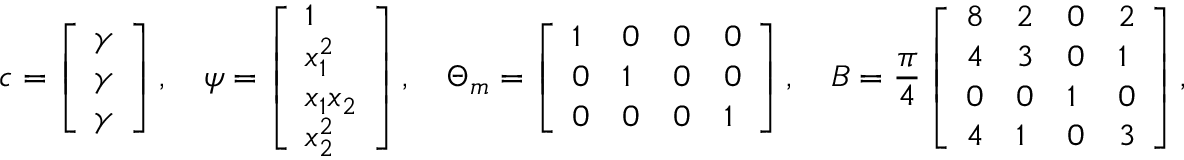<formula> <loc_0><loc_0><loc_500><loc_500>c = \left [ \begin{array} { l } { \gamma } \\ { \gamma } \\ { \gamma } \end{array} \right ] , \quad \psi = \left [ \begin{array} { l } { 1 } \\ { x _ { 1 } ^ { 2 } } \\ { x _ { 1 } x _ { 2 } } \\ { x _ { 2 } ^ { 2 } } \end{array} \right ] , \quad \Theta _ { m } = \left [ \begin{array} { l l l l } { 1 } & { 0 } & { 0 } & { 0 } \\ { 0 } & { 1 } & { 0 } & { 0 } \\ { 0 } & { 0 } & { 0 } & { 1 } \end{array} \right ] , \quad B = \frac { \pi } { 4 } \left [ \begin{array} { l l l l } { 8 } & { 2 } & { 0 } & { 2 } \\ { 4 } & { 3 } & { 0 } & { 1 } \\ { 0 } & { 0 } & { 1 } & { 0 } \\ { 4 } & { 1 } & { 0 } & { 3 } \end{array} \right ] ,</formula> 